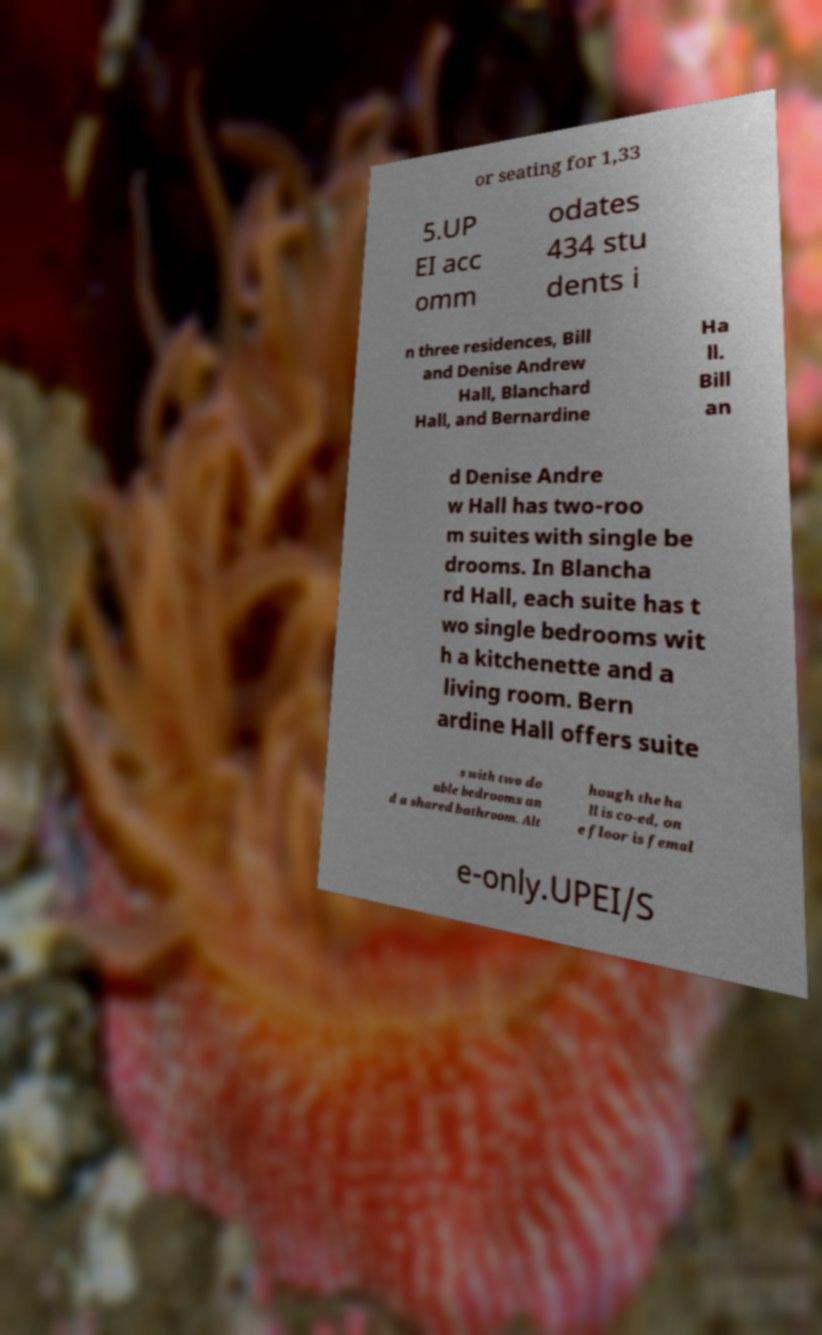There's text embedded in this image that I need extracted. Can you transcribe it verbatim? or seating for 1,33 5.UP EI acc omm odates 434 stu dents i n three residences, Bill and Denise Andrew Hall, Blanchard Hall, and Bernardine Ha ll. Bill an d Denise Andre w Hall has two-roo m suites with single be drooms. In Blancha rd Hall, each suite has t wo single bedrooms wit h a kitchenette and a living room. Bern ardine Hall offers suite s with two do uble bedrooms an d a shared bathroom. Alt hough the ha ll is co-ed, on e floor is femal e-only.UPEI/S 